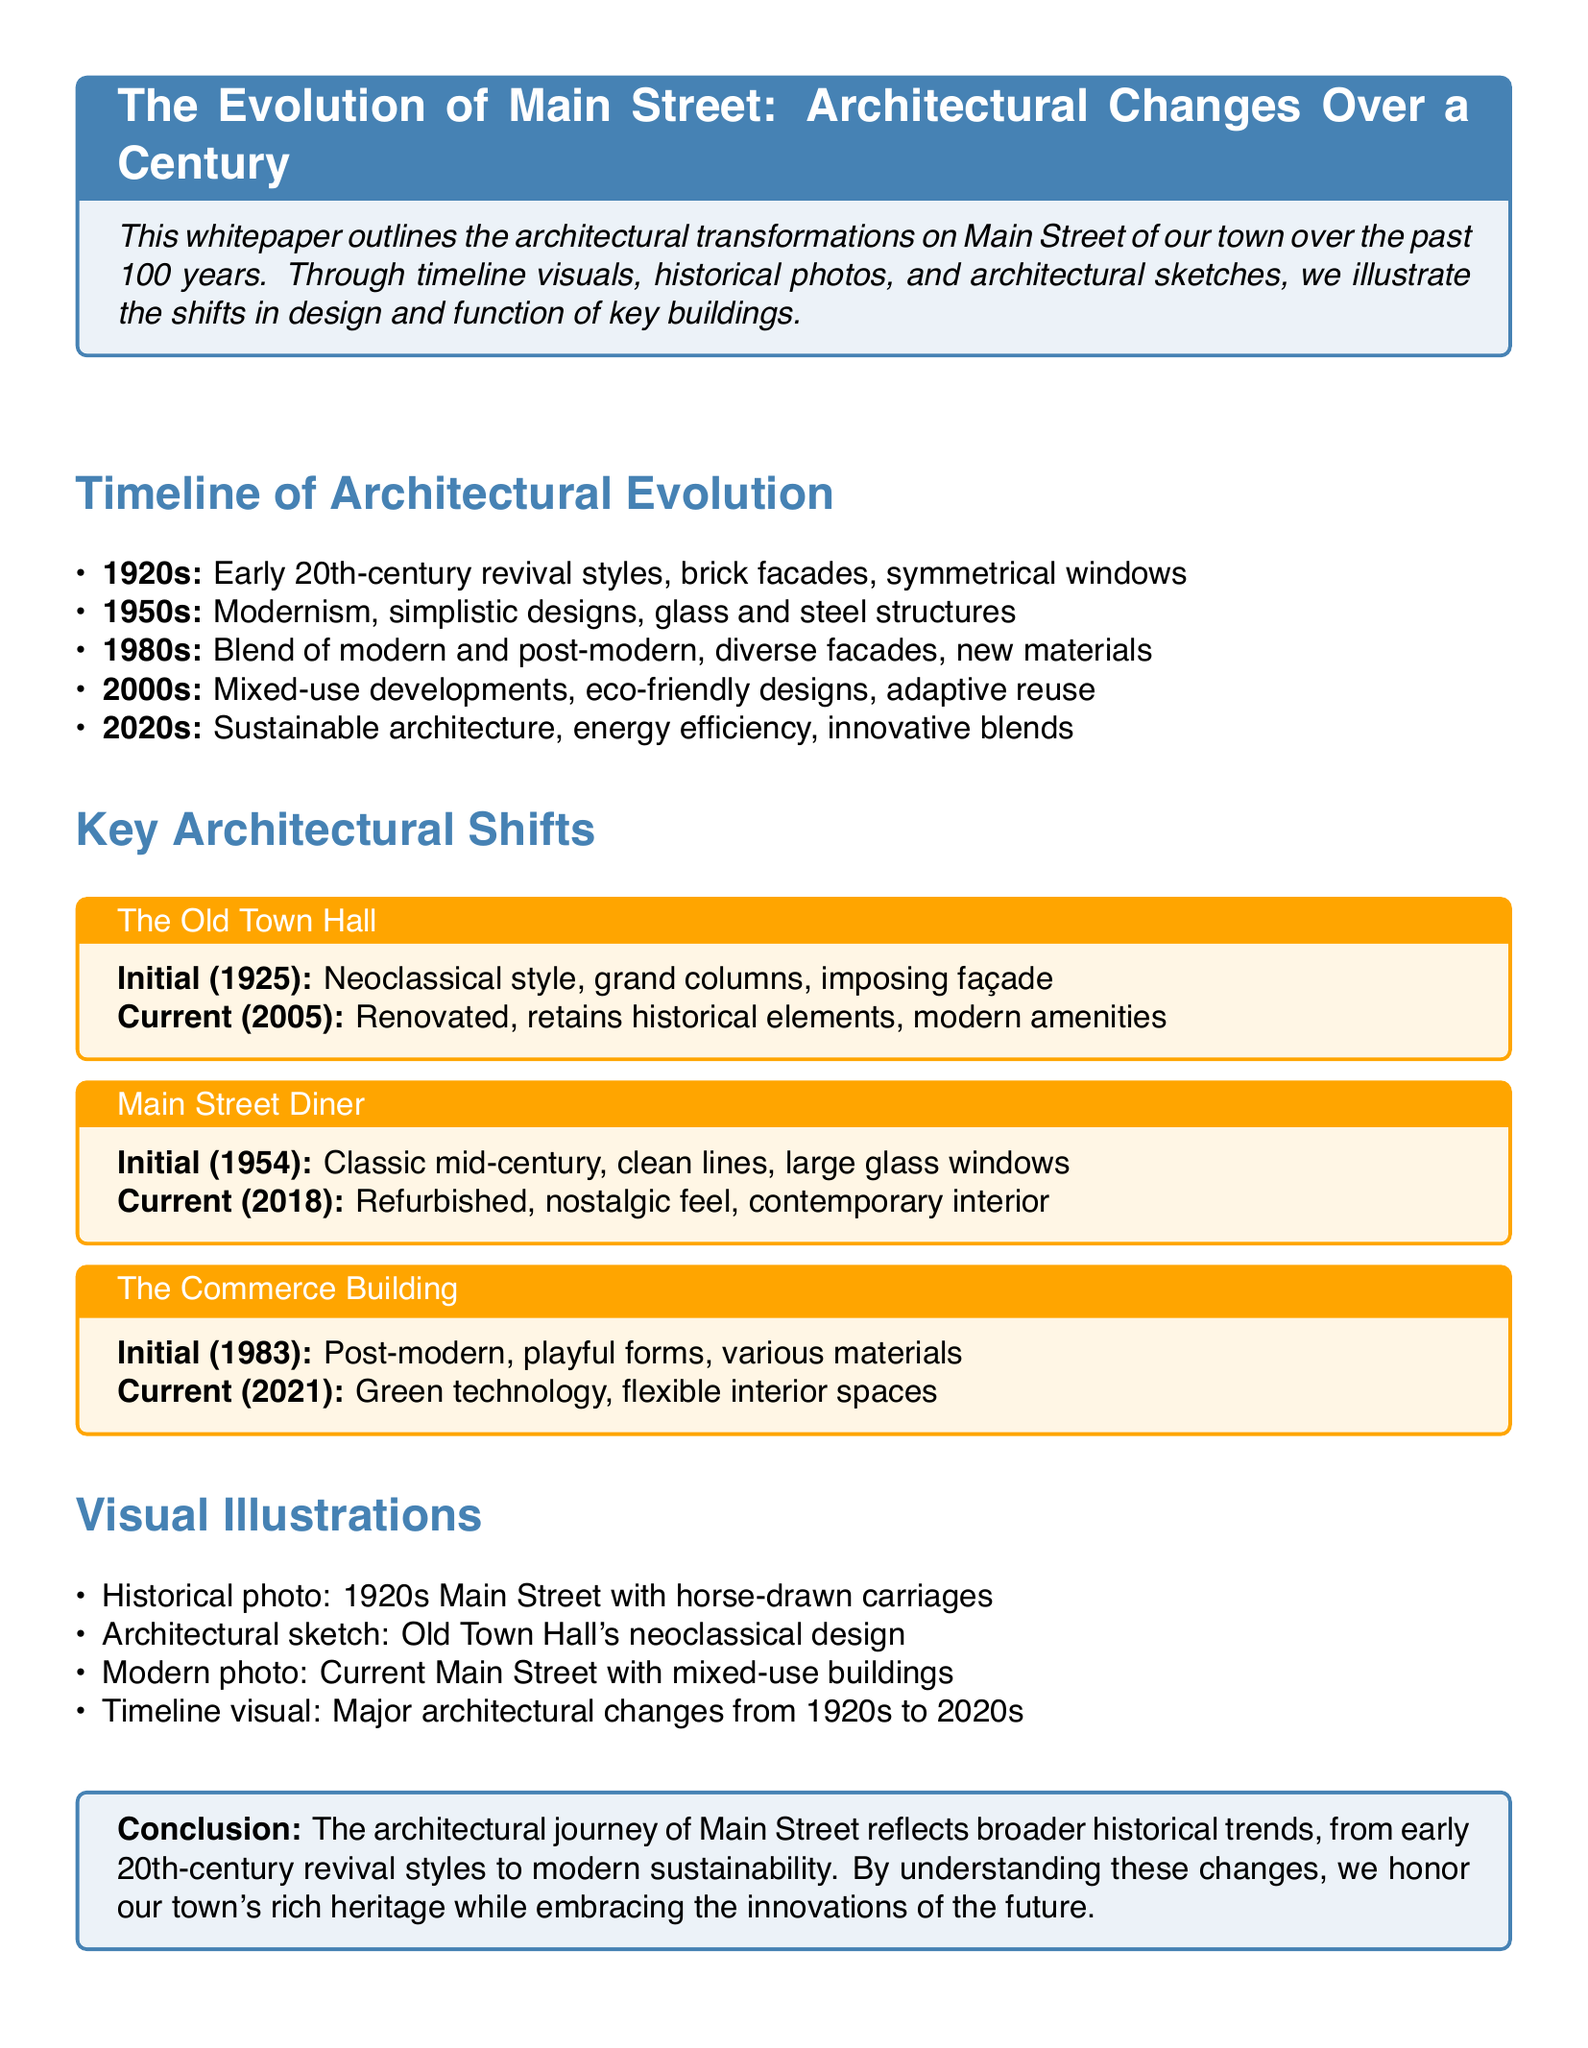What architectural style was prominent in the 1920s? The document mentions that early 20th-century revival styles with brick facades and symmetrical windows were prevalent during the 1920s.
Answer: Early 20th-century revival styles What year was the Old Town Hall built? The initial construction date of the Old Town Hall is provided in the document as 1925.
Answer: 1925 What is a key feature of the Main Street Diner's initial design? The document states the diner had clean lines and large glass windows in its mid-century design.
Answer: Clean lines, large glass windows Which decade introduced modernism in architecture? The document explicitly mentions the 1950s as the time when modernism became significant in architectural design.
Answer: 1950s What type of technology was incorporated in the Commerce Building during its current renovation? The document indicates that green technology is part of the current renovations of the Commerce Building.
Answer: Green technology How did Main Street's architectural design change in the 2000s? According to the document, the 2000s saw a rise in mixed-use developments and eco-friendly designs.
Answer: Mixed-use developments, eco-friendly designs What was the prominent aesthetic approach in the 1980s? The document describes the 1980s as a blend of modern and post-modern architectural styles, featuring diverse facades and new materials.
Answer: Blend of modern and post-modern What visual element is included to illustrate architectural changes? The document lists a timeline visual as one of the elements used to depict major architectural changes.
Answer: Timeline visual What is emphasized in the conclusion of the document? The conclusion highlights the importance of understanding the architectural journey in relation to historical trends and innovations.
Answer: Historical trends, innovations 